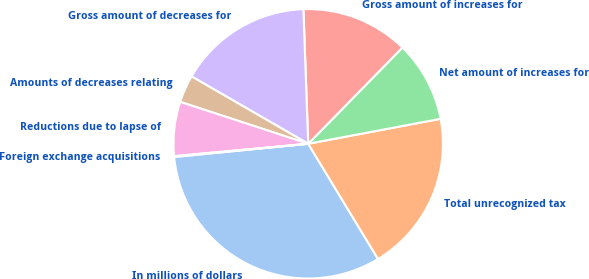Convert chart. <chart><loc_0><loc_0><loc_500><loc_500><pie_chart><fcel>In millions of dollars<fcel>Total unrecognized tax<fcel>Net amount of increases for<fcel>Gross amount of increases for<fcel>Gross amount of decreases for<fcel>Amounts of decreases relating<fcel>Reductions due to lapse of<fcel>Foreign exchange acquisitions<nl><fcel>32.11%<fcel>19.3%<fcel>9.7%<fcel>12.9%<fcel>16.1%<fcel>3.3%<fcel>6.5%<fcel>0.1%<nl></chart> 